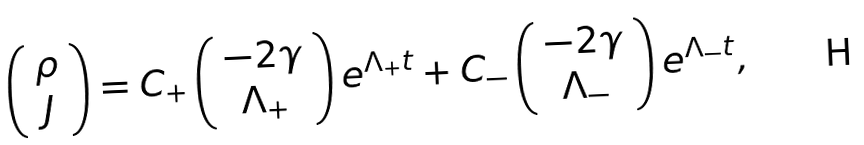<formula> <loc_0><loc_0><loc_500><loc_500>\left ( \begin{array} { c } \rho \\ J \\ \end{array} \right ) = C _ { + } \left ( \begin{array} { c } - 2 \gamma \\ \Lambda _ { + } \\ \end{array} \right ) e ^ { \Lambda _ { + } t } + C _ { - } \left ( \begin{array} { c } - 2 \gamma \\ \Lambda _ { - } \\ \end{array} \right ) e ^ { \Lambda _ { - } t } ,</formula> 